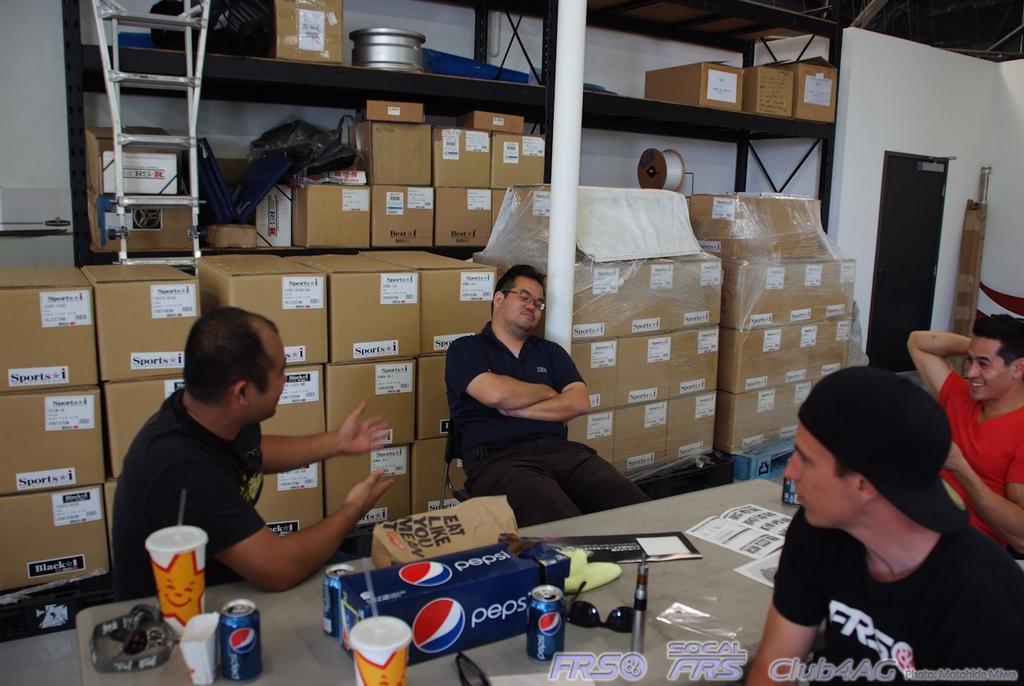Please provide a concise description of this image. This is indoor picture. There are many cardboard boxes. This rack is in black color. The pole is in white color. Inside this rock there is a container. In-front of this rock there is a ladder. These 4 persons are sitting on a chair. In-front of this person's there is a table, on a table there are goggles, tin, cup and box. This person wore cap. The red t-shirt person is smiling. The black t-shirt person wore spectacles. The door. The wall is in white color. 